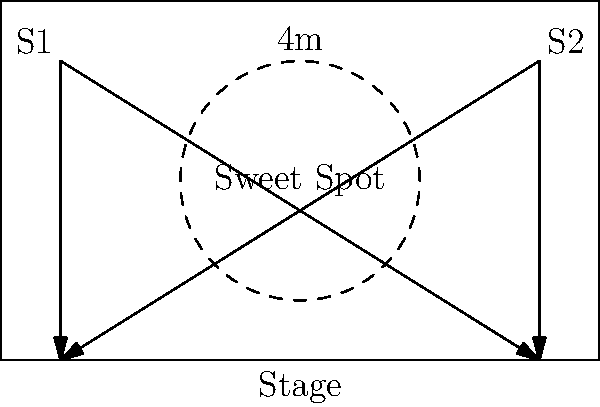In your vintage theater, you've identified the "sweet spot" where sound waves from two speakers (S1 and S2) converge optimally. This area is represented by a circle with a radius of 2 meters at the center of the auditorium. If the distance between the two speakers is 8 meters, what is the area of the "sweet spot" in square meters? Round your answer to two decimal places. To solve this problem, we'll follow these steps:

1) The "sweet spot" is represented by a circle in the center of the auditorium.

2) We're given that the radius of this circle is 2 meters.

3) To calculate the area of a circle, we use the formula:

   $$A = \pi r^2$$

   Where:
   $A$ is the area
   $\pi$ is pi (approximately 3.14159)
   $r$ is the radius

4) Substituting our known value:

   $$A = \pi (2)^2$$

5) Simplify:

   $$A = \pi (4)$$
   $$A = 4\pi$$

6) Calculate and round to two decimal places:

   $$A \approx 12.57 \text{ square meters}$$

Thus, the area of the "sweet spot" is approximately 12.57 square meters.
Answer: 12.57 m² 